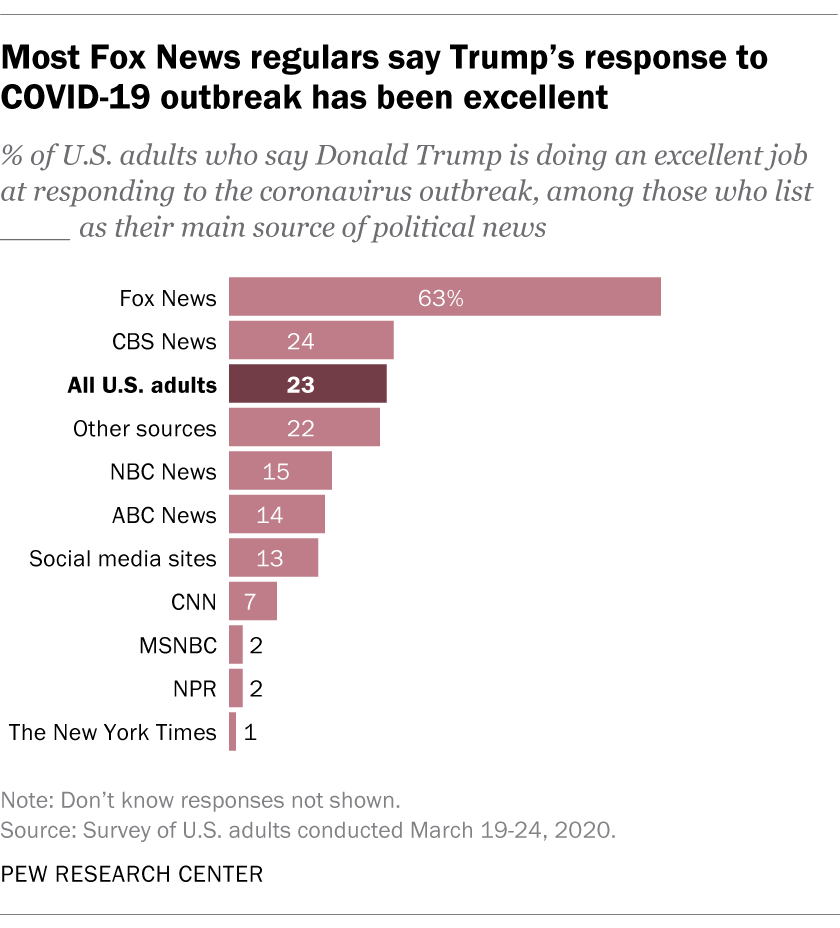Highlight a few significant elements in this photo. Fox News has the highest value among all news sources. Yes, there are two news channels with the same value. 